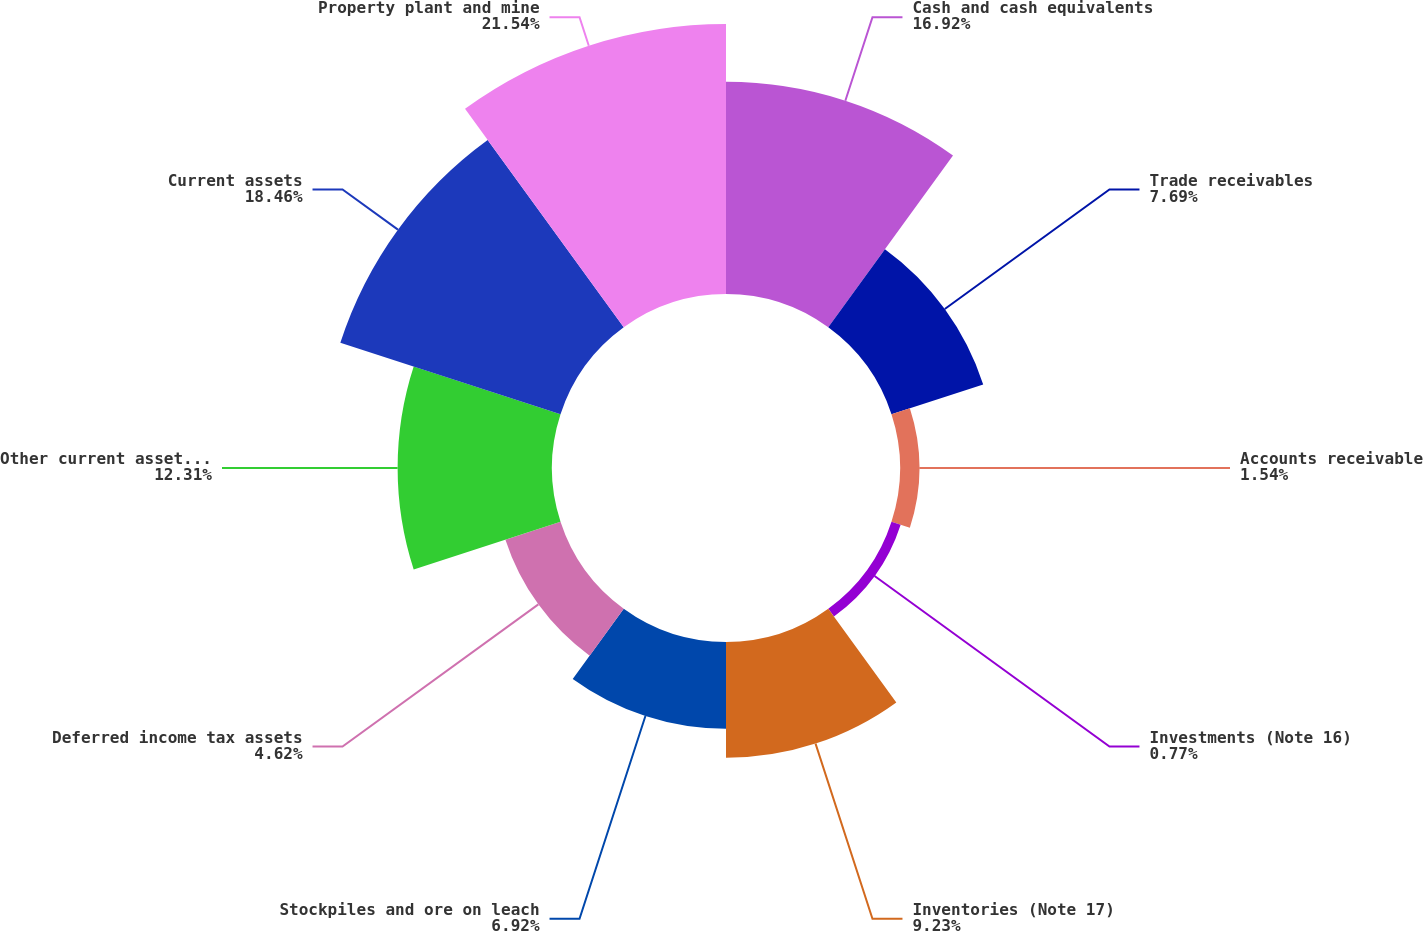Convert chart. <chart><loc_0><loc_0><loc_500><loc_500><pie_chart><fcel>Cash and cash equivalents<fcel>Trade receivables<fcel>Accounts receivable<fcel>Investments (Note 16)<fcel>Inventories (Note 17)<fcel>Stockpiles and ore on leach<fcel>Deferred income tax assets<fcel>Other current assets (Note 19)<fcel>Current assets<fcel>Property plant and mine<nl><fcel>16.92%<fcel>7.69%<fcel>1.54%<fcel>0.77%<fcel>9.23%<fcel>6.92%<fcel>4.62%<fcel>12.31%<fcel>18.46%<fcel>21.53%<nl></chart> 